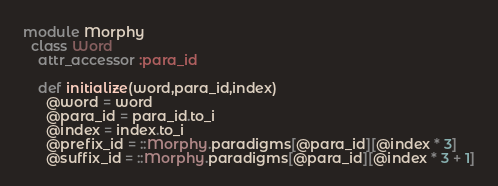Convert code to text. <code><loc_0><loc_0><loc_500><loc_500><_Ruby_>module Morphy
  class Word
    attr_accessor :para_id

    def initialize(word,para_id,index)
      @word = word
      @para_id = para_id.to_i
      @index = index.to_i
      @prefix_id = ::Morphy.paradigms[@para_id][@index * 3]
      @suffix_id = ::Morphy.paradigms[@para_id][@index * 3 + 1]</code> 